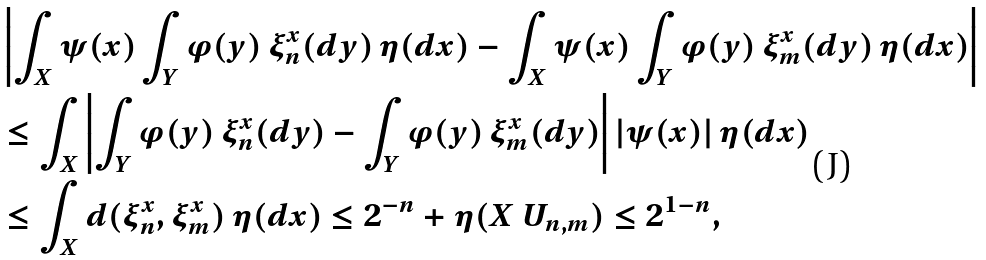<formula> <loc_0><loc_0><loc_500><loc_500>& \left | \int _ { X } \psi ( x ) \int _ { Y } \varphi ( y ) \, \xi _ { n } ^ { x } ( d y ) \, \eta ( d x ) - \int _ { X } \psi ( x ) \int _ { Y } \varphi ( y ) \, \xi _ { m } ^ { x } ( d y ) \, \eta ( d x ) \right | \\ & \leq \int _ { X } \left | \int _ { Y } \varphi ( y ) \, \xi _ { n } ^ { x } ( d y ) - \int _ { Y } \varphi ( y ) \, \xi _ { m } ^ { x } ( d y ) \right | | \psi ( x ) | \, \eta ( d x ) \\ & \leq \int _ { X } d ( \xi _ { n } ^ { x } , \xi _ { m } ^ { x } ) \, \eta ( d x ) \leq 2 ^ { - n } + \eta ( X \ U _ { n , m } ) \leq 2 ^ { 1 - n } ,</formula> 